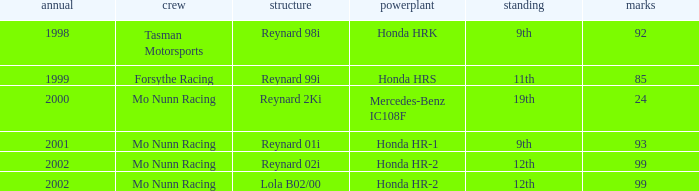What is the rank of the reynard 2ki chassis before 2002? 19th. 